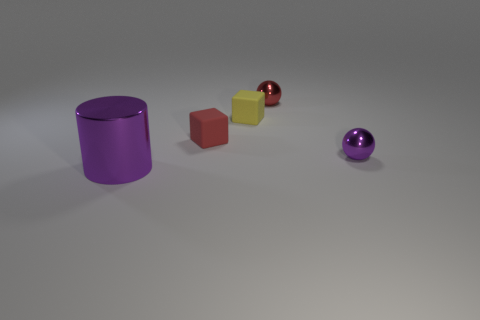Add 4 purple metallic cylinders. How many objects exist? 9 Subtract all blocks. How many objects are left? 3 Add 2 purple shiny things. How many purple shiny things exist? 4 Subtract 0 green cylinders. How many objects are left? 5 Subtract all red matte objects. Subtract all red matte cubes. How many objects are left? 3 Add 5 small shiny balls. How many small shiny balls are left? 7 